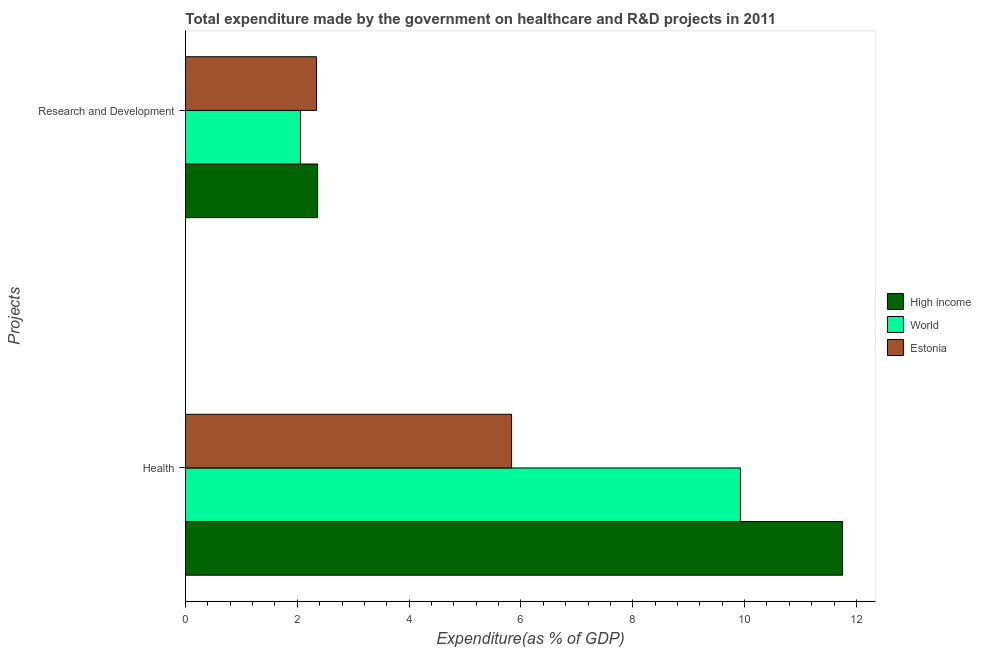How many different coloured bars are there?
Provide a short and direct response. 3. Are the number of bars per tick equal to the number of legend labels?
Provide a short and direct response. Yes. Are the number of bars on each tick of the Y-axis equal?
Make the answer very short. Yes. How many bars are there on the 2nd tick from the top?
Provide a short and direct response. 3. How many bars are there on the 2nd tick from the bottom?
Offer a very short reply. 3. What is the label of the 1st group of bars from the top?
Ensure brevity in your answer.  Research and Development. What is the expenditure in r&d in World?
Offer a terse response. 2.06. Across all countries, what is the maximum expenditure in r&d?
Your response must be concise. 2.36. Across all countries, what is the minimum expenditure in r&d?
Provide a short and direct response. 2.06. In which country was the expenditure in r&d maximum?
Provide a succinct answer. High income. What is the total expenditure in healthcare in the graph?
Offer a terse response. 27.51. What is the difference between the expenditure in healthcare in World and that in High income?
Your answer should be very brief. -1.83. What is the difference between the expenditure in healthcare in World and the expenditure in r&d in Estonia?
Offer a terse response. 7.58. What is the average expenditure in r&d per country?
Your response must be concise. 2.25. What is the difference between the expenditure in healthcare and expenditure in r&d in Estonia?
Offer a terse response. 3.49. In how many countries, is the expenditure in healthcare greater than 7.2 %?
Your answer should be very brief. 2. What is the ratio of the expenditure in healthcare in High income to that in World?
Make the answer very short. 1.18. Is the expenditure in healthcare in World less than that in Estonia?
Provide a succinct answer. No. What does the 1st bar from the top in Health represents?
Your response must be concise. Estonia. What is the difference between two consecutive major ticks on the X-axis?
Ensure brevity in your answer.  2. Are the values on the major ticks of X-axis written in scientific E-notation?
Your response must be concise. No. How many legend labels are there?
Give a very brief answer. 3. What is the title of the graph?
Your answer should be very brief. Total expenditure made by the government on healthcare and R&D projects in 2011. What is the label or title of the X-axis?
Provide a succinct answer. Expenditure(as % of GDP). What is the label or title of the Y-axis?
Your response must be concise. Projects. What is the Expenditure(as % of GDP) in High income in Health?
Provide a short and direct response. 11.75. What is the Expenditure(as % of GDP) of World in Health?
Offer a terse response. 9.93. What is the Expenditure(as % of GDP) of Estonia in Health?
Your answer should be very brief. 5.83. What is the Expenditure(as % of GDP) in High income in Research and Development?
Offer a terse response. 2.36. What is the Expenditure(as % of GDP) of World in Research and Development?
Your response must be concise. 2.06. What is the Expenditure(as % of GDP) of Estonia in Research and Development?
Provide a short and direct response. 2.34. Across all Projects, what is the maximum Expenditure(as % of GDP) in High income?
Your answer should be very brief. 11.75. Across all Projects, what is the maximum Expenditure(as % of GDP) of World?
Your response must be concise. 9.93. Across all Projects, what is the maximum Expenditure(as % of GDP) in Estonia?
Give a very brief answer. 5.83. Across all Projects, what is the minimum Expenditure(as % of GDP) in High income?
Provide a succinct answer. 2.36. Across all Projects, what is the minimum Expenditure(as % of GDP) in World?
Provide a short and direct response. 2.06. Across all Projects, what is the minimum Expenditure(as % of GDP) of Estonia?
Offer a terse response. 2.34. What is the total Expenditure(as % of GDP) in High income in the graph?
Ensure brevity in your answer.  14.12. What is the total Expenditure(as % of GDP) of World in the graph?
Your answer should be compact. 11.98. What is the total Expenditure(as % of GDP) of Estonia in the graph?
Give a very brief answer. 8.18. What is the difference between the Expenditure(as % of GDP) in High income in Health and that in Research and Development?
Your response must be concise. 9.39. What is the difference between the Expenditure(as % of GDP) of World in Health and that in Research and Development?
Provide a short and direct response. 7.87. What is the difference between the Expenditure(as % of GDP) in Estonia in Health and that in Research and Development?
Your answer should be very brief. 3.49. What is the difference between the Expenditure(as % of GDP) of High income in Health and the Expenditure(as % of GDP) of World in Research and Development?
Ensure brevity in your answer.  9.7. What is the difference between the Expenditure(as % of GDP) of High income in Health and the Expenditure(as % of GDP) of Estonia in Research and Development?
Offer a very short reply. 9.41. What is the difference between the Expenditure(as % of GDP) in World in Health and the Expenditure(as % of GDP) in Estonia in Research and Development?
Make the answer very short. 7.58. What is the average Expenditure(as % of GDP) of High income per Projects?
Your answer should be compact. 7.06. What is the average Expenditure(as % of GDP) of World per Projects?
Your answer should be compact. 5.99. What is the average Expenditure(as % of GDP) in Estonia per Projects?
Give a very brief answer. 4.09. What is the difference between the Expenditure(as % of GDP) of High income and Expenditure(as % of GDP) of World in Health?
Your answer should be very brief. 1.83. What is the difference between the Expenditure(as % of GDP) in High income and Expenditure(as % of GDP) in Estonia in Health?
Keep it short and to the point. 5.92. What is the difference between the Expenditure(as % of GDP) in World and Expenditure(as % of GDP) in Estonia in Health?
Keep it short and to the point. 4.09. What is the difference between the Expenditure(as % of GDP) in High income and Expenditure(as % of GDP) in World in Research and Development?
Your answer should be very brief. 0.31. What is the difference between the Expenditure(as % of GDP) in High income and Expenditure(as % of GDP) in Estonia in Research and Development?
Provide a short and direct response. 0.02. What is the difference between the Expenditure(as % of GDP) in World and Expenditure(as % of GDP) in Estonia in Research and Development?
Your answer should be very brief. -0.29. What is the ratio of the Expenditure(as % of GDP) of High income in Health to that in Research and Development?
Give a very brief answer. 4.97. What is the ratio of the Expenditure(as % of GDP) of World in Health to that in Research and Development?
Your answer should be compact. 4.82. What is the ratio of the Expenditure(as % of GDP) in Estonia in Health to that in Research and Development?
Keep it short and to the point. 2.49. What is the difference between the highest and the second highest Expenditure(as % of GDP) of High income?
Ensure brevity in your answer.  9.39. What is the difference between the highest and the second highest Expenditure(as % of GDP) in World?
Provide a short and direct response. 7.87. What is the difference between the highest and the second highest Expenditure(as % of GDP) in Estonia?
Give a very brief answer. 3.49. What is the difference between the highest and the lowest Expenditure(as % of GDP) in High income?
Keep it short and to the point. 9.39. What is the difference between the highest and the lowest Expenditure(as % of GDP) of World?
Ensure brevity in your answer.  7.87. What is the difference between the highest and the lowest Expenditure(as % of GDP) of Estonia?
Ensure brevity in your answer.  3.49. 